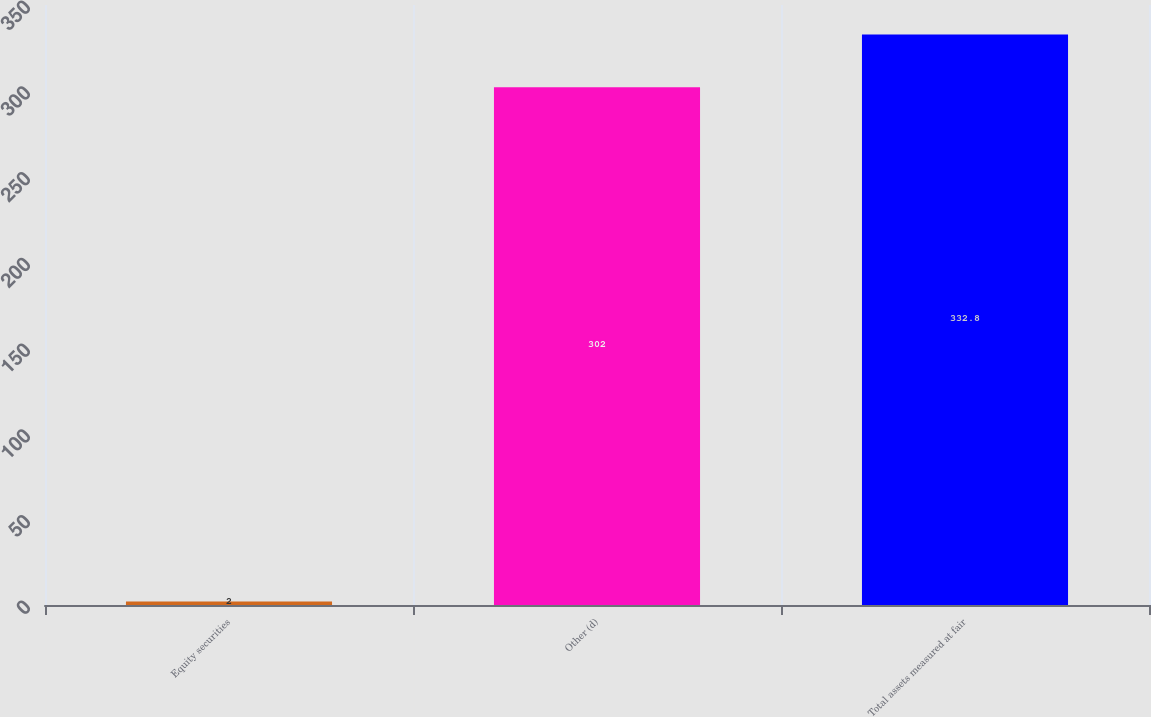Convert chart. <chart><loc_0><loc_0><loc_500><loc_500><bar_chart><fcel>Equity securities<fcel>Other (d)<fcel>Total assets measured at fair<nl><fcel>2<fcel>302<fcel>332.8<nl></chart> 